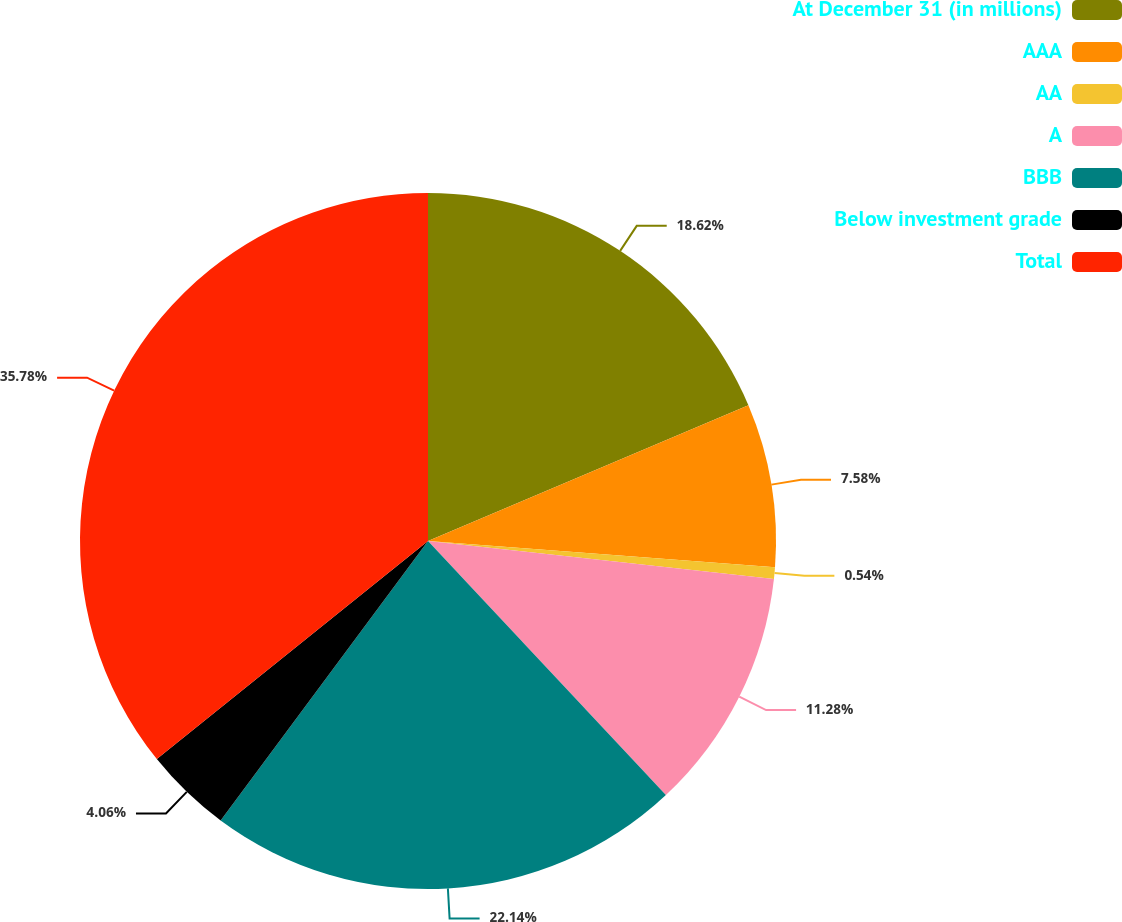<chart> <loc_0><loc_0><loc_500><loc_500><pie_chart><fcel>At December 31 (in millions)<fcel>AAA<fcel>AA<fcel>A<fcel>BBB<fcel>Below investment grade<fcel>Total<nl><fcel>18.62%<fcel>7.58%<fcel>0.54%<fcel>11.28%<fcel>22.14%<fcel>4.06%<fcel>35.78%<nl></chart> 